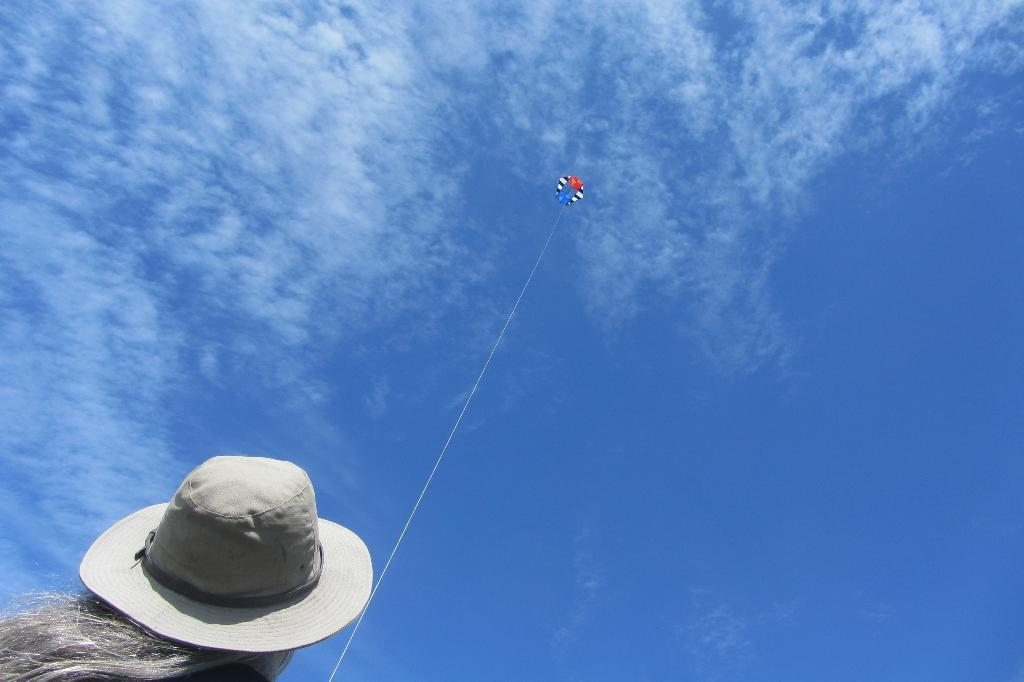Who is the main subject in the image? There is a girl in the image. Where is the girl located in the image? The girl is at the bottom side of the image. What is the girl doing in the image? The girl is flying a kite. What type of nut can be seen falling from the tree in the image? There is no tree or nut present in the image; the girl is flying a kite. 